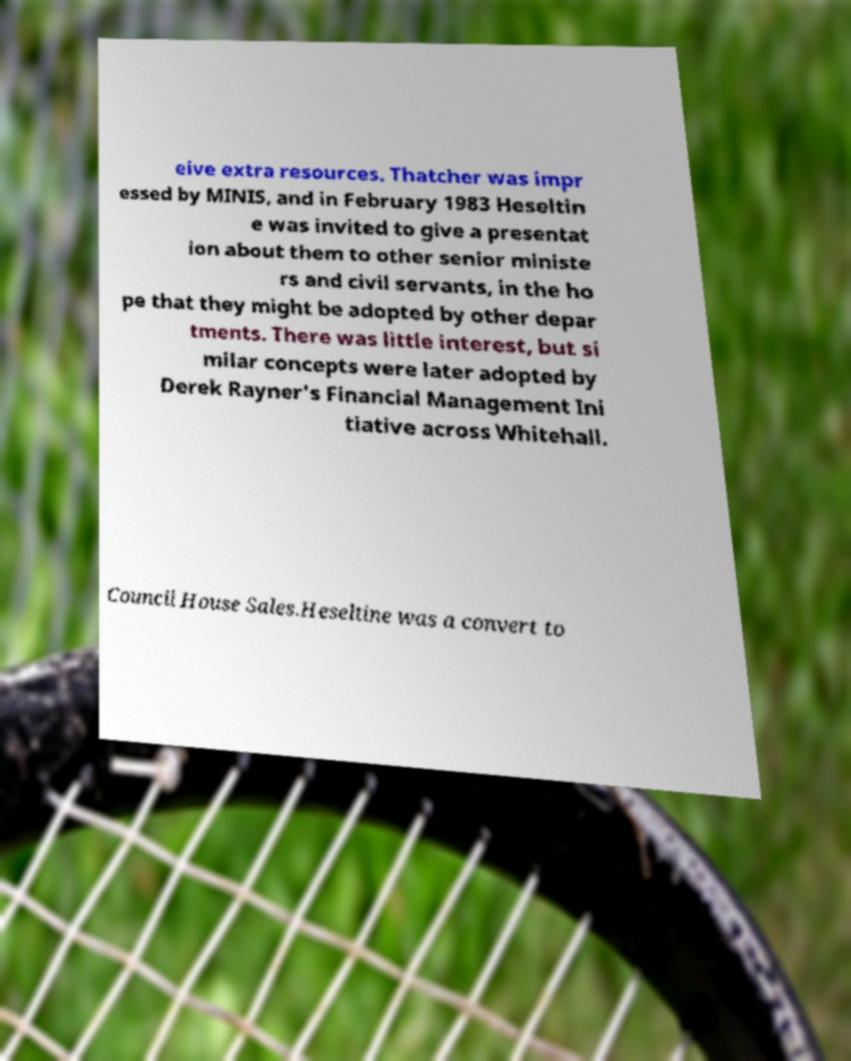There's text embedded in this image that I need extracted. Can you transcribe it verbatim? eive extra resources. Thatcher was impr essed by MINIS, and in February 1983 Heseltin e was invited to give a presentat ion about them to other senior ministe rs and civil servants, in the ho pe that they might be adopted by other depar tments. There was little interest, but si milar concepts were later adopted by Derek Rayner's Financial Management Ini tiative across Whitehall. Council House Sales.Heseltine was a convert to 